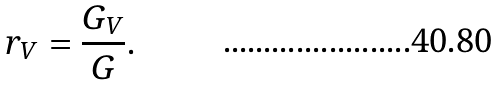<formula> <loc_0><loc_0><loc_500><loc_500>r _ { V } = \frac { G _ { V } } { G } .</formula> 